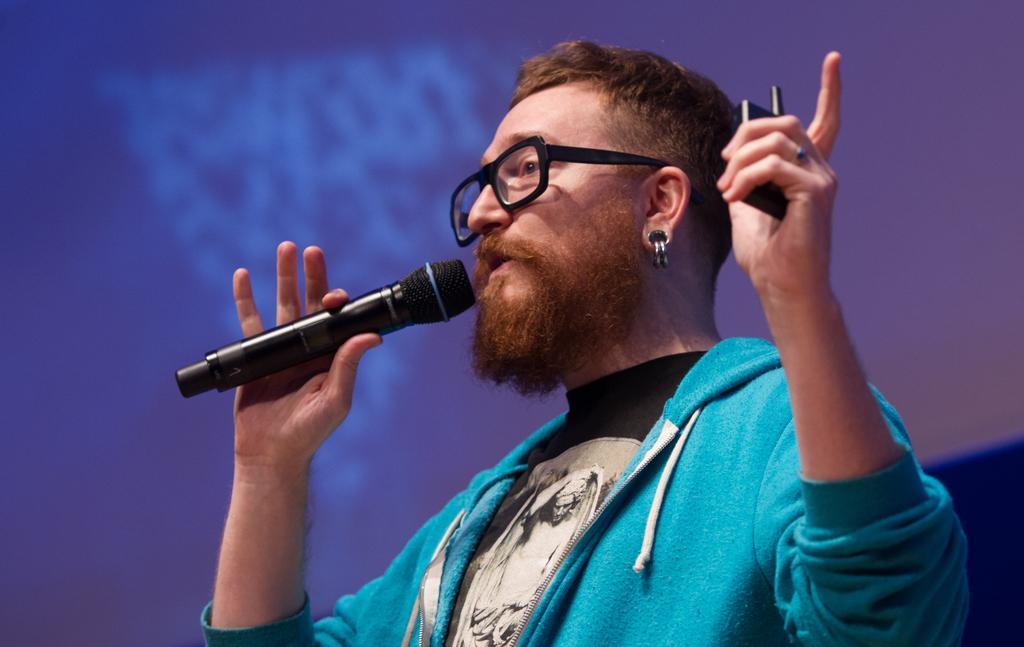Describe this image in one or two sentences. This image consists of a man wearing a blue jacket. He is holding a mic. In the background, we can see a screen in blue color. 